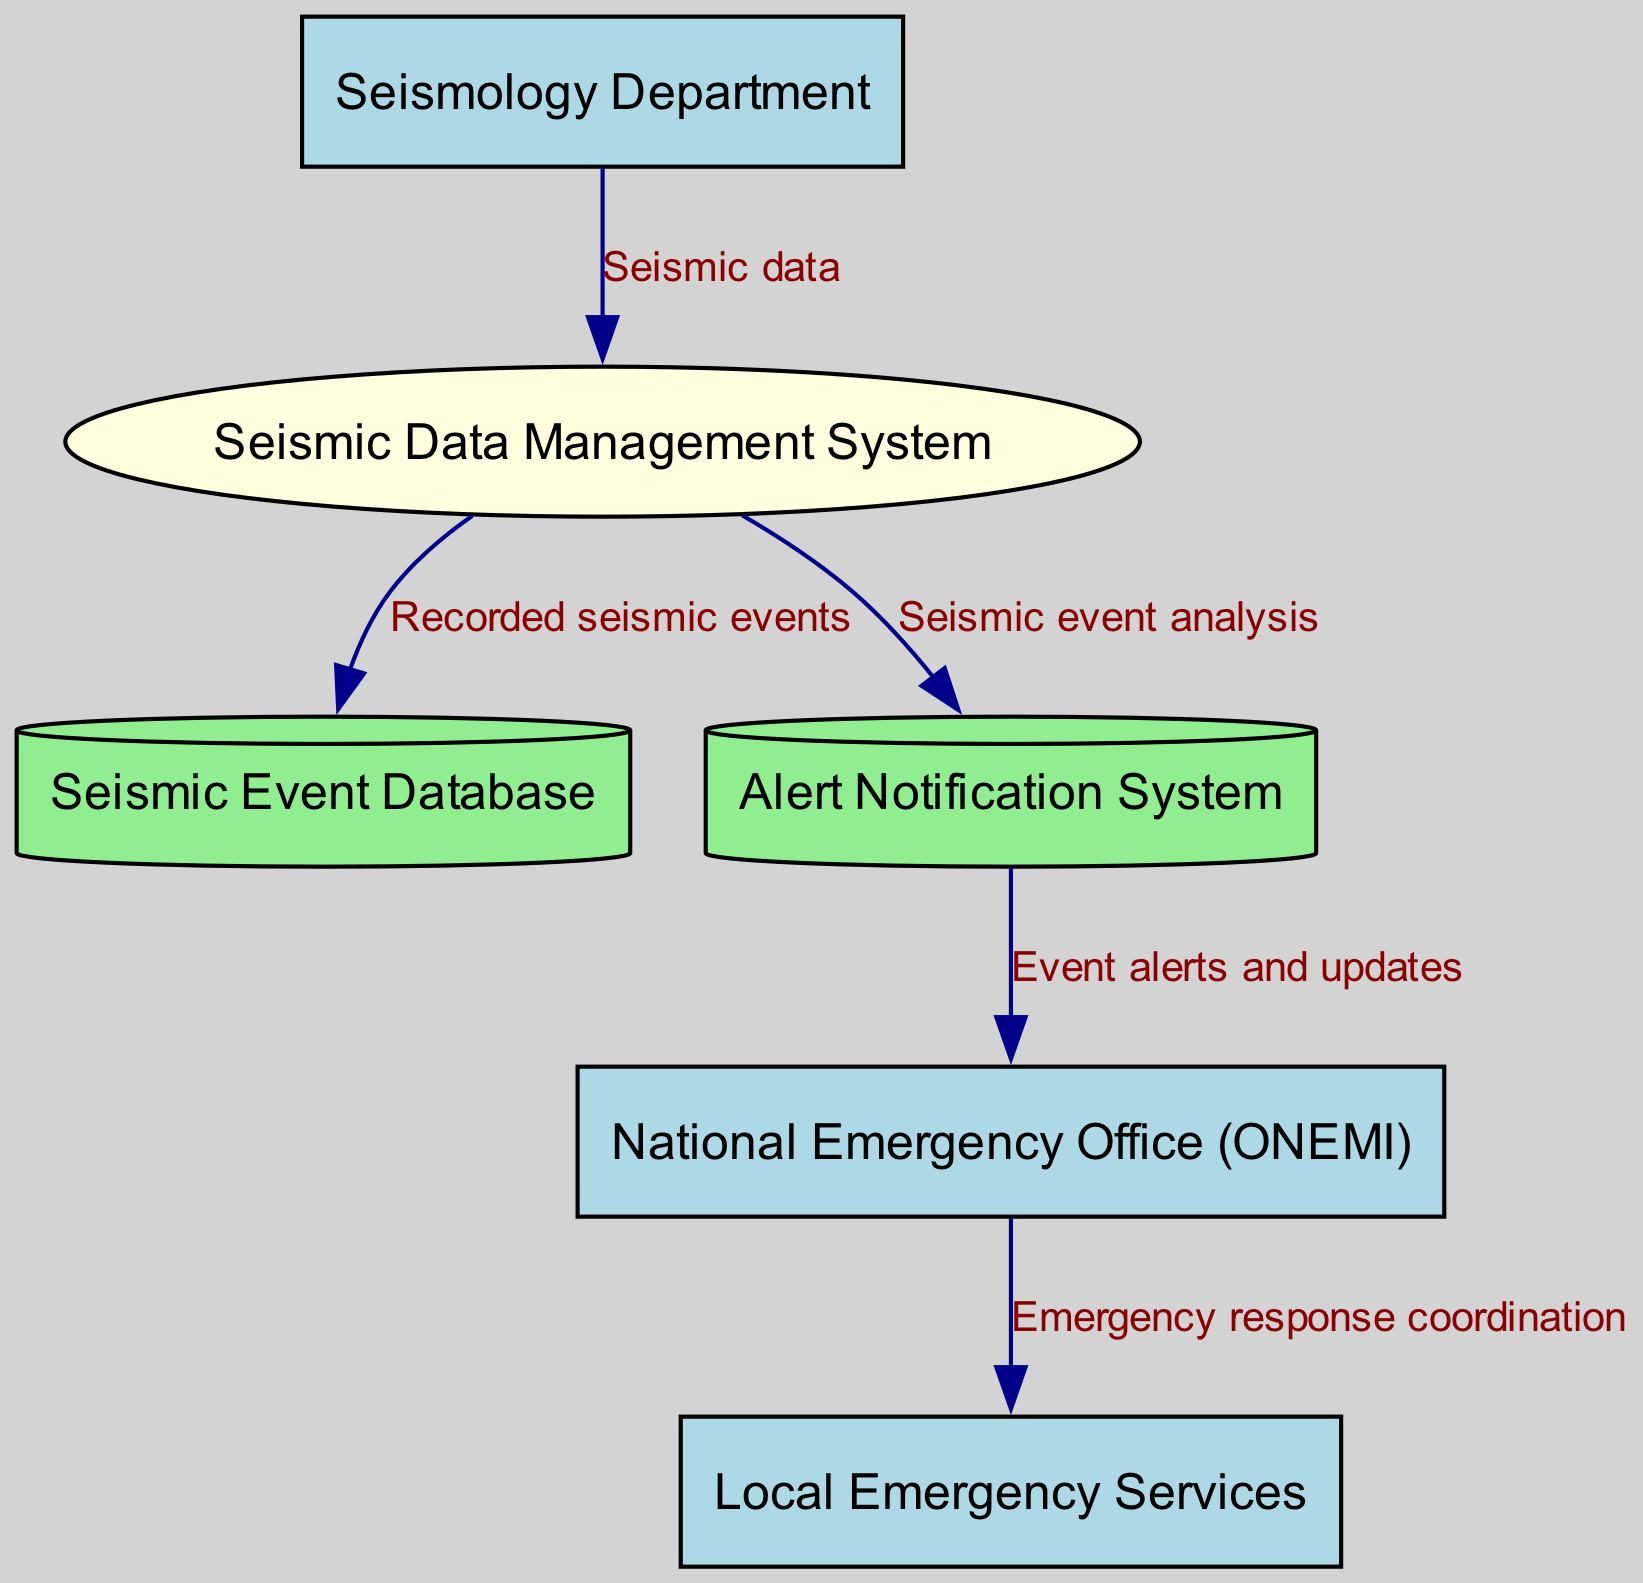What's the role of the Seismology Department in the diagram? The Seismology Department's role is to provide seismic data to the Seismic Data Management System, which initiates the workflow of data processing and communication to emergency services.
Answer: Seismic data provider How many data stores are represented in the diagram? There are two data stores in the diagram: the Seismic Event Database and the Alert Notification System.
Answer: Two What type of flow occurs from the Alert Notification System to the National Emergency Office (ONEMI)? The flow from the Alert Notification System to the National Emergency Office is an alert flow, which consists of event alerts and updates communicated to the emergency office for further action.
Answer: Event alerts and updates Which entity receives emergency response coordination from the National Emergency Office (ONEMI)? The Local Emergency Services receive emergency response coordination from the National Emergency Office (ONEMI), indicating a direct line of communication for coordinated disaster response.
Answer: Local Emergency Services What is the first step in the disaster response coordination process? The first step involves the Seismology Department sending seismic data to the Seismic Data Management System, initiating the data management and analysis process needed for effective disaster response coordination.
Answer: Seismic data sent What happens to the seismic data within the Seismic Data Management System? Within the Seismic Data Management System, the seismic data is processed and leads to the recording of seismic events in the Seismic Event Database, as well as the analysis that triggers alerts.
Answer: Recorded seismic events What type of system is the Seismic Data Management System categorized as? The Seismic Data Management System is categorized as a process in the diagram, indicating it performs actions on the seismic data it receives.
Answer: Process What flows from the Seismic Data Management System to the Alert Notification System? Seismic event analysis flows from the Seismic Data Management System to the Alert Notification System, serving to inform subsequent alerting procedures.
Answer: Seismic event analysis How many external entities are involved in this communication flow? There are three external entities involved in this communication flow: Seismology Department, National Emergency Office (ONEMI), and Local Emergency Services.
Answer: Three 